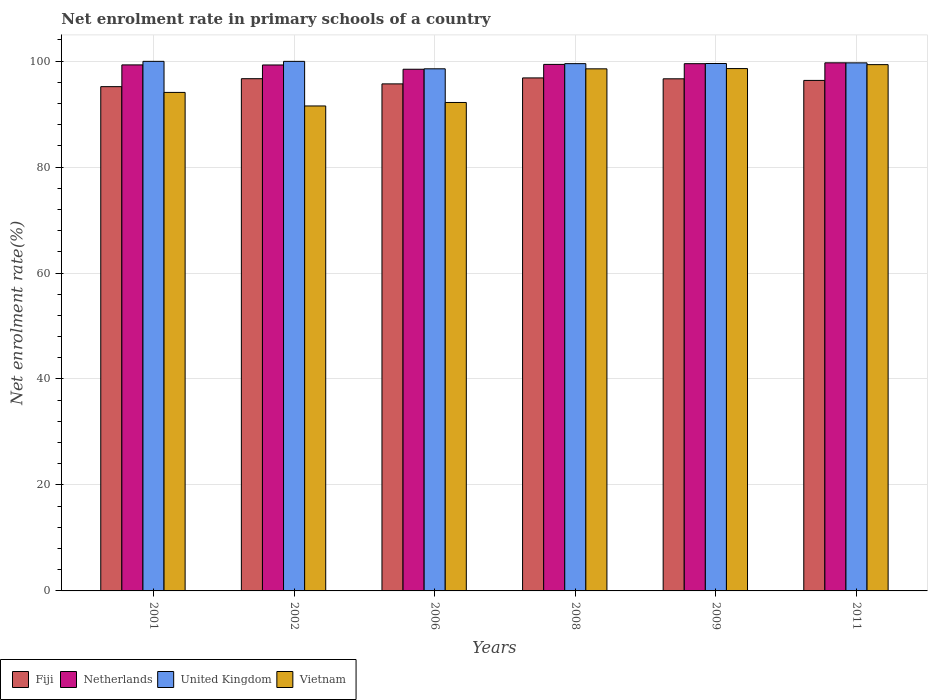How many different coloured bars are there?
Offer a terse response. 4. Are the number of bars on each tick of the X-axis equal?
Ensure brevity in your answer.  Yes. How many bars are there on the 6th tick from the left?
Offer a very short reply. 4. What is the net enrolment rate in primary schools in Vietnam in 2009?
Your answer should be very brief. 98.58. Across all years, what is the maximum net enrolment rate in primary schools in Vietnam?
Make the answer very short. 99.32. Across all years, what is the minimum net enrolment rate in primary schools in Vietnam?
Give a very brief answer. 91.53. In which year was the net enrolment rate in primary schools in Fiji minimum?
Provide a succinct answer. 2001. What is the total net enrolment rate in primary schools in Vietnam in the graph?
Ensure brevity in your answer.  574.23. What is the difference between the net enrolment rate in primary schools in Vietnam in 2009 and that in 2011?
Offer a very short reply. -0.74. What is the difference between the net enrolment rate in primary schools in United Kingdom in 2009 and the net enrolment rate in primary schools in Fiji in 2006?
Your answer should be compact. 3.85. What is the average net enrolment rate in primary schools in United Kingdom per year?
Offer a terse response. 99.52. In the year 2009, what is the difference between the net enrolment rate in primary schools in Fiji and net enrolment rate in primary schools in United Kingdom?
Your answer should be very brief. -2.89. In how many years, is the net enrolment rate in primary schools in Netherlands greater than 64 %?
Offer a very short reply. 6. What is the ratio of the net enrolment rate in primary schools in Fiji in 2001 to that in 2008?
Ensure brevity in your answer.  0.98. Is the net enrolment rate in primary schools in Vietnam in 2002 less than that in 2008?
Provide a succinct answer. Yes. What is the difference between the highest and the second highest net enrolment rate in primary schools in Netherlands?
Provide a short and direct response. 0.16. What is the difference between the highest and the lowest net enrolment rate in primary schools in United Kingdom?
Ensure brevity in your answer.  1.41. Is the sum of the net enrolment rate in primary schools in Vietnam in 2006 and 2011 greater than the maximum net enrolment rate in primary schools in Fiji across all years?
Your answer should be very brief. Yes. What does the 4th bar from the right in 2009 represents?
Ensure brevity in your answer.  Fiji. How many years are there in the graph?
Your response must be concise. 6. How many legend labels are there?
Provide a succinct answer. 4. What is the title of the graph?
Your answer should be very brief. Net enrolment rate in primary schools of a country. What is the label or title of the X-axis?
Provide a succinct answer. Years. What is the label or title of the Y-axis?
Your response must be concise. Net enrolment rate(%). What is the Net enrolment rate(%) of Fiji in 2001?
Provide a succinct answer. 95.17. What is the Net enrolment rate(%) of Netherlands in 2001?
Provide a succinct answer. 99.28. What is the Net enrolment rate(%) in United Kingdom in 2001?
Provide a succinct answer. 99.94. What is the Net enrolment rate(%) in Vietnam in 2001?
Ensure brevity in your answer.  94.08. What is the Net enrolment rate(%) in Fiji in 2002?
Offer a terse response. 96.67. What is the Net enrolment rate(%) of Netherlands in 2002?
Make the answer very short. 99.26. What is the Net enrolment rate(%) in United Kingdom in 2002?
Keep it short and to the point. 99.94. What is the Net enrolment rate(%) in Vietnam in 2002?
Ensure brevity in your answer.  91.53. What is the Net enrolment rate(%) of Fiji in 2006?
Your answer should be very brief. 95.69. What is the Net enrolment rate(%) in Netherlands in 2006?
Your answer should be very brief. 98.46. What is the Net enrolment rate(%) of United Kingdom in 2006?
Offer a terse response. 98.54. What is the Net enrolment rate(%) of Vietnam in 2006?
Your response must be concise. 92.18. What is the Net enrolment rate(%) of Fiji in 2008?
Offer a very short reply. 96.82. What is the Net enrolment rate(%) of Netherlands in 2008?
Offer a terse response. 99.37. What is the Net enrolment rate(%) in United Kingdom in 2008?
Make the answer very short. 99.51. What is the Net enrolment rate(%) of Vietnam in 2008?
Keep it short and to the point. 98.53. What is the Net enrolment rate(%) in Fiji in 2009?
Keep it short and to the point. 96.65. What is the Net enrolment rate(%) of Netherlands in 2009?
Provide a short and direct response. 99.5. What is the Net enrolment rate(%) in United Kingdom in 2009?
Keep it short and to the point. 99.54. What is the Net enrolment rate(%) in Vietnam in 2009?
Your answer should be very brief. 98.58. What is the Net enrolment rate(%) of Fiji in 2011?
Offer a terse response. 96.35. What is the Net enrolment rate(%) of Netherlands in 2011?
Keep it short and to the point. 99.67. What is the Net enrolment rate(%) in United Kingdom in 2011?
Offer a very short reply. 99.66. What is the Net enrolment rate(%) in Vietnam in 2011?
Offer a very short reply. 99.32. Across all years, what is the maximum Net enrolment rate(%) of Fiji?
Give a very brief answer. 96.82. Across all years, what is the maximum Net enrolment rate(%) in Netherlands?
Provide a short and direct response. 99.67. Across all years, what is the maximum Net enrolment rate(%) of United Kingdom?
Your answer should be compact. 99.94. Across all years, what is the maximum Net enrolment rate(%) of Vietnam?
Offer a very short reply. 99.32. Across all years, what is the minimum Net enrolment rate(%) of Fiji?
Keep it short and to the point. 95.17. Across all years, what is the minimum Net enrolment rate(%) in Netherlands?
Your answer should be very brief. 98.46. Across all years, what is the minimum Net enrolment rate(%) of United Kingdom?
Give a very brief answer. 98.54. Across all years, what is the minimum Net enrolment rate(%) of Vietnam?
Give a very brief answer. 91.53. What is the total Net enrolment rate(%) of Fiji in the graph?
Ensure brevity in your answer.  577.35. What is the total Net enrolment rate(%) in Netherlands in the graph?
Offer a very short reply. 595.54. What is the total Net enrolment rate(%) of United Kingdom in the graph?
Ensure brevity in your answer.  597.13. What is the total Net enrolment rate(%) of Vietnam in the graph?
Keep it short and to the point. 574.23. What is the difference between the Net enrolment rate(%) of Fiji in 2001 and that in 2002?
Provide a short and direct response. -1.5. What is the difference between the Net enrolment rate(%) in Netherlands in 2001 and that in 2002?
Keep it short and to the point. 0.01. What is the difference between the Net enrolment rate(%) in United Kingdom in 2001 and that in 2002?
Keep it short and to the point. 0. What is the difference between the Net enrolment rate(%) in Vietnam in 2001 and that in 2002?
Your answer should be compact. 2.56. What is the difference between the Net enrolment rate(%) of Fiji in 2001 and that in 2006?
Give a very brief answer. -0.52. What is the difference between the Net enrolment rate(%) of Netherlands in 2001 and that in 2006?
Keep it short and to the point. 0.82. What is the difference between the Net enrolment rate(%) of United Kingdom in 2001 and that in 2006?
Your answer should be very brief. 1.41. What is the difference between the Net enrolment rate(%) of Vietnam in 2001 and that in 2006?
Ensure brevity in your answer.  1.9. What is the difference between the Net enrolment rate(%) of Fiji in 2001 and that in 2008?
Keep it short and to the point. -1.65. What is the difference between the Net enrolment rate(%) of Netherlands in 2001 and that in 2008?
Your answer should be very brief. -0.09. What is the difference between the Net enrolment rate(%) in United Kingdom in 2001 and that in 2008?
Ensure brevity in your answer.  0.43. What is the difference between the Net enrolment rate(%) of Vietnam in 2001 and that in 2008?
Your response must be concise. -4.45. What is the difference between the Net enrolment rate(%) of Fiji in 2001 and that in 2009?
Provide a succinct answer. -1.48. What is the difference between the Net enrolment rate(%) of Netherlands in 2001 and that in 2009?
Your answer should be compact. -0.23. What is the difference between the Net enrolment rate(%) of United Kingdom in 2001 and that in 2009?
Your answer should be compact. 0.41. What is the difference between the Net enrolment rate(%) of Vietnam in 2001 and that in 2009?
Keep it short and to the point. -4.5. What is the difference between the Net enrolment rate(%) of Fiji in 2001 and that in 2011?
Offer a very short reply. -1.17. What is the difference between the Net enrolment rate(%) in Netherlands in 2001 and that in 2011?
Your answer should be very brief. -0.39. What is the difference between the Net enrolment rate(%) in United Kingdom in 2001 and that in 2011?
Keep it short and to the point. 0.29. What is the difference between the Net enrolment rate(%) in Vietnam in 2001 and that in 2011?
Your response must be concise. -5.24. What is the difference between the Net enrolment rate(%) in Fiji in 2002 and that in 2006?
Your answer should be compact. 0.98. What is the difference between the Net enrolment rate(%) of Netherlands in 2002 and that in 2006?
Provide a short and direct response. 0.81. What is the difference between the Net enrolment rate(%) of United Kingdom in 2002 and that in 2006?
Provide a short and direct response. 1.41. What is the difference between the Net enrolment rate(%) of Vietnam in 2002 and that in 2006?
Provide a succinct answer. -0.66. What is the difference between the Net enrolment rate(%) in Fiji in 2002 and that in 2008?
Your answer should be compact. -0.15. What is the difference between the Net enrolment rate(%) in Netherlands in 2002 and that in 2008?
Offer a terse response. -0.11. What is the difference between the Net enrolment rate(%) of United Kingdom in 2002 and that in 2008?
Your answer should be very brief. 0.43. What is the difference between the Net enrolment rate(%) of Vietnam in 2002 and that in 2008?
Offer a terse response. -7.01. What is the difference between the Net enrolment rate(%) in Fiji in 2002 and that in 2009?
Your answer should be very brief. 0.02. What is the difference between the Net enrolment rate(%) of Netherlands in 2002 and that in 2009?
Ensure brevity in your answer.  -0.24. What is the difference between the Net enrolment rate(%) of United Kingdom in 2002 and that in 2009?
Provide a succinct answer. 0.4. What is the difference between the Net enrolment rate(%) of Vietnam in 2002 and that in 2009?
Your answer should be very brief. -7.06. What is the difference between the Net enrolment rate(%) in Fiji in 2002 and that in 2011?
Give a very brief answer. 0.33. What is the difference between the Net enrolment rate(%) in Netherlands in 2002 and that in 2011?
Your answer should be compact. -0.41. What is the difference between the Net enrolment rate(%) of United Kingdom in 2002 and that in 2011?
Ensure brevity in your answer.  0.28. What is the difference between the Net enrolment rate(%) in Vietnam in 2002 and that in 2011?
Give a very brief answer. -7.8. What is the difference between the Net enrolment rate(%) in Fiji in 2006 and that in 2008?
Keep it short and to the point. -1.13. What is the difference between the Net enrolment rate(%) of Netherlands in 2006 and that in 2008?
Offer a very short reply. -0.91. What is the difference between the Net enrolment rate(%) in United Kingdom in 2006 and that in 2008?
Provide a short and direct response. -0.98. What is the difference between the Net enrolment rate(%) of Vietnam in 2006 and that in 2008?
Offer a terse response. -6.35. What is the difference between the Net enrolment rate(%) in Fiji in 2006 and that in 2009?
Provide a short and direct response. -0.96. What is the difference between the Net enrolment rate(%) in Netherlands in 2006 and that in 2009?
Your answer should be compact. -1.05. What is the difference between the Net enrolment rate(%) in United Kingdom in 2006 and that in 2009?
Ensure brevity in your answer.  -1. What is the difference between the Net enrolment rate(%) in Vietnam in 2006 and that in 2009?
Provide a succinct answer. -6.4. What is the difference between the Net enrolment rate(%) in Fiji in 2006 and that in 2011?
Ensure brevity in your answer.  -0.65. What is the difference between the Net enrolment rate(%) of Netherlands in 2006 and that in 2011?
Keep it short and to the point. -1.21. What is the difference between the Net enrolment rate(%) in United Kingdom in 2006 and that in 2011?
Provide a succinct answer. -1.12. What is the difference between the Net enrolment rate(%) in Vietnam in 2006 and that in 2011?
Offer a terse response. -7.14. What is the difference between the Net enrolment rate(%) in Fiji in 2008 and that in 2009?
Keep it short and to the point. 0.17. What is the difference between the Net enrolment rate(%) of Netherlands in 2008 and that in 2009?
Provide a short and direct response. -0.13. What is the difference between the Net enrolment rate(%) of United Kingdom in 2008 and that in 2009?
Your answer should be compact. -0.03. What is the difference between the Net enrolment rate(%) in Vietnam in 2008 and that in 2009?
Offer a very short reply. -0.05. What is the difference between the Net enrolment rate(%) of Fiji in 2008 and that in 2011?
Your response must be concise. 0.47. What is the difference between the Net enrolment rate(%) in Netherlands in 2008 and that in 2011?
Give a very brief answer. -0.3. What is the difference between the Net enrolment rate(%) of United Kingdom in 2008 and that in 2011?
Ensure brevity in your answer.  -0.15. What is the difference between the Net enrolment rate(%) of Vietnam in 2008 and that in 2011?
Provide a succinct answer. -0.79. What is the difference between the Net enrolment rate(%) of Fiji in 2009 and that in 2011?
Give a very brief answer. 0.31. What is the difference between the Net enrolment rate(%) in Netherlands in 2009 and that in 2011?
Your response must be concise. -0.16. What is the difference between the Net enrolment rate(%) in United Kingdom in 2009 and that in 2011?
Your answer should be compact. -0.12. What is the difference between the Net enrolment rate(%) in Vietnam in 2009 and that in 2011?
Make the answer very short. -0.74. What is the difference between the Net enrolment rate(%) of Fiji in 2001 and the Net enrolment rate(%) of Netherlands in 2002?
Your answer should be compact. -4.09. What is the difference between the Net enrolment rate(%) of Fiji in 2001 and the Net enrolment rate(%) of United Kingdom in 2002?
Make the answer very short. -4.77. What is the difference between the Net enrolment rate(%) of Fiji in 2001 and the Net enrolment rate(%) of Vietnam in 2002?
Your answer should be compact. 3.65. What is the difference between the Net enrolment rate(%) in Netherlands in 2001 and the Net enrolment rate(%) in Vietnam in 2002?
Offer a very short reply. 7.75. What is the difference between the Net enrolment rate(%) in United Kingdom in 2001 and the Net enrolment rate(%) in Vietnam in 2002?
Your answer should be compact. 8.42. What is the difference between the Net enrolment rate(%) of Fiji in 2001 and the Net enrolment rate(%) of Netherlands in 2006?
Give a very brief answer. -3.28. What is the difference between the Net enrolment rate(%) in Fiji in 2001 and the Net enrolment rate(%) in United Kingdom in 2006?
Make the answer very short. -3.37. What is the difference between the Net enrolment rate(%) of Fiji in 2001 and the Net enrolment rate(%) of Vietnam in 2006?
Keep it short and to the point. 2.99. What is the difference between the Net enrolment rate(%) of Netherlands in 2001 and the Net enrolment rate(%) of United Kingdom in 2006?
Offer a terse response. 0.74. What is the difference between the Net enrolment rate(%) in Netherlands in 2001 and the Net enrolment rate(%) in Vietnam in 2006?
Give a very brief answer. 7.09. What is the difference between the Net enrolment rate(%) of United Kingdom in 2001 and the Net enrolment rate(%) of Vietnam in 2006?
Keep it short and to the point. 7.76. What is the difference between the Net enrolment rate(%) of Fiji in 2001 and the Net enrolment rate(%) of Netherlands in 2008?
Provide a succinct answer. -4.2. What is the difference between the Net enrolment rate(%) of Fiji in 2001 and the Net enrolment rate(%) of United Kingdom in 2008?
Keep it short and to the point. -4.34. What is the difference between the Net enrolment rate(%) in Fiji in 2001 and the Net enrolment rate(%) in Vietnam in 2008?
Keep it short and to the point. -3.36. What is the difference between the Net enrolment rate(%) of Netherlands in 2001 and the Net enrolment rate(%) of United Kingdom in 2008?
Give a very brief answer. -0.24. What is the difference between the Net enrolment rate(%) in Netherlands in 2001 and the Net enrolment rate(%) in Vietnam in 2008?
Provide a short and direct response. 0.75. What is the difference between the Net enrolment rate(%) in United Kingdom in 2001 and the Net enrolment rate(%) in Vietnam in 2008?
Your response must be concise. 1.41. What is the difference between the Net enrolment rate(%) in Fiji in 2001 and the Net enrolment rate(%) in Netherlands in 2009?
Offer a very short reply. -4.33. What is the difference between the Net enrolment rate(%) of Fiji in 2001 and the Net enrolment rate(%) of United Kingdom in 2009?
Make the answer very short. -4.37. What is the difference between the Net enrolment rate(%) in Fiji in 2001 and the Net enrolment rate(%) in Vietnam in 2009?
Provide a succinct answer. -3.41. What is the difference between the Net enrolment rate(%) in Netherlands in 2001 and the Net enrolment rate(%) in United Kingdom in 2009?
Make the answer very short. -0.26. What is the difference between the Net enrolment rate(%) of Netherlands in 2001 and the Net enrolment rate(%) of Vietnam in 2009?
Your answer should be compact. 0.69. What is the difference between the Net enrolment rate(%) in United Kingdom in 2001 and the Net enrolment rate(%) in Vietnam in 2009?
Provide a short and direct response. 1.36. What is the difference between the Net enrolment rate(%) of Fiji in 2001 and the Net enrolment rate(%) of Netherlands in 2011?
Make the answer very short. -4.5. What is the difference between the Net enrolment rate(%) in Fiji in 2001 and the Net enrolment rate(%) in United Kingdom in 2011?
Give a very brief answer. -4.49. What is the difference between the Net enrolment rate(%) in Fiji in 2001 and the Net enrolment rate(%) in Vietnam in 2011?
Your answer should be compact. -4.15. What is the difference between the Net enrolment rate(%) of Netherlands in 2001 and the Net enrolment rate(%) of United Kingdom in 2011?
Your answer should be very brief. -0.38. What is the difference between the Net enrolment rate(%) of Netherlands in 2001 and the Net enrolment rate(%) of Vietnam in 2011?
Offer a very short reply. -0.05. What is the difference between the Net enrolment rate(%) in United Kingdom in 2001 and the Net enrolment rate(%) in Vietnam in 2011?
Ensure brevity in your answer.  0.62. What is the difference between the Net enrolment rate(%) in Fiji in 2002 and the Net enrolment rate(%) in Netherlands in 2006?
Provide a short and direct response. -1.78. What is the difference between the Net enrolment rate(%) in Fiji in 2002 and the Net enrolment rate(%) in United Kingdom in 2006?
Offer a terse response. -1.86. What is the difference between the Net enrolment rate(%) of Fiji in 2002 and the Net enrolment rate(%) of Vietnam in 2006?
Keep it short and to the point. 4.49. What is the difference between the Net enrolment rate(%) of Netherlands in 2002 and the Net enrolment rate(%) of United Kingdom in 2006?
Give a very brief answer. 0.72. What is the difference between the Net enrolment rate(%) in Netherlands in 2002 and the Net enrolment rate(%) in Vietnam in 2006?
Provide a succinct answer. 7.08. What is the difference between the Net enrolment rate(%) in United Kingdom in 2002 and the Net enrolment rate(%) in Vietnam in 2006?
Your answer should be very brief. 7.76. What is the difference between the Net enrolment rate(%) in Fiji in 2002 and the Net enrolment rate(%) in Netherlands in 2008?
Keep it short and to the point. -2.7. What is the difference between the Net enrolment rate(%) in Fiji in 2002 and the Net enrolment rate(%) in United Kingdom in 2008?
Give a very brief answer. -2.84. What is the difference between the Net enrolment rate(%) of Fiji in 2002 and the Net enrolment rate(%) of Vietnam in 2008?
Ensure brevity in your answer.  -1.86. What is the difference between the Net enrolment rate(%) of Netherlands in 2002 and the Net enrolment rate(%) of United Kingdom in 2008?
Provide a short and direct response. -0.25. What is the difference between the Net enrolment rate(%) in Netherlands in 2002 and the Net enrolment rate(%) in Vietnam in 2008?
Provide a succinct answer. 0.73. What is the difference between the Net enrolment rate(%) in United Kingdom in 2002 and the Net enrolment rate(%) in Vietnam in 2008?
Your answer should be very brief. 1.41. What is the difference between the Net enrolment rate(%) of Fiji in 2002 and the Net enrolment rate(%) of Netherlands in 2009?
Provide a succinct answer. -2.83. What is the difference between the Net enrolment rate(%) in Fiji in 2002 and the Net enrolment rate(%) in United Kingdom in 2009?
Keep it short and to the point. -2.87. What is the difference between the Net enrolment rate(%) in Fiji in 2002 and the Net enrolment rate(%) in Vietnam in 2009?
Provide a short and direct response. -1.91. What is the difference between the Net enrolment rate(%) of Netherlands in 2002 and the Net enrolment rate(%) of United Kingdom in 2009?
Ensure brevity in your answer.  -0.28. What is the difference between the Net enrolment rate(%) in Netherlands in 2002 and the Net enrolment rate(%) in Vietnam in 2009?
Ensure brevity in your answer.  0.68. What is the difference between the Net enrolment rate(%) of United Kingdom in 2002 and the Net enrolment rate(%) of Vietnam in 2009?
Make the answer very short. 1.36. What is the difference between the Net enrolment rate(%) of Fiji in 2002 and the Net enrolment rate(%) of Netherlands in 2011?
Provide a succinct answer. -3. What is the difference between the Net enrolment rate(%) in Fiji in 2002 and the Net enrolment rate(%) in United Kingdom in 2011?
Give a very brief answer. -2.99. What is the difference between the Net enrolment rate(%) in Fiji in 2002 and the Net enrolment rate(%) in Vietnam in 2011?
Ensure brevity in your answer.  -2.65. What is the difference between the Net enrolment rate(%) of Netherlands in 2002 and the Net enrolment rate(%) of United Kingdom in 2011?
Provide a succinct answer. -0.4. What is the difference between the Net enrolment rate(%) in Netherlands in 2002 and the Net enrolment rate(%) in Vietnam in 2011?
Provide a short and direct response. -0.06. What is the difference between the Net enrolment rate(%) in United Kingdom in 2002 and the Net enrolment rate(%) in Vietnam in 2011?
Keep it short and to the point. 0.62. What is the difference between the Net enrolment rate(%) of Fiji in 2006 and the Net enrolment rate(%) of Netherlands in 2008?
Make the answer very short. -3.68. What is the difference between the Net enrolment rate(%) of Fiji in 2006 and the Net enrolment rate(%) of United Kingdom in 2008?
Offer a terse response. -3.82. What is the difference between the Net enrolment rate(%) in Fiji in 2006 and the Net enrolment rate(%) in Vietnam in 2008?
Ensure brevity in your answer.  -2.84. What is the difference between the Net enrolment rate(%) of Netherlands in 2006 and the Net enrolment rate(%) of United Kingdom in 2008?
Make the answer very short. -1.06. What is the difference between the Net enrolment rate(%) in Netherlands in 2006 and the Net enrolment rate(%) in Vietnam in 2008?
Offer a very short reply. -0.07. What is the difference between the Net enrolment rate(%) of United Kingdom in 2006 and the Net enrolment rate(%) of Vietnam in 2008?
Make the answer very short. 0.01. What is the difference between the Net enrolment rate(%) of Fiji in 2006 and the Net enrolment rate(%) of Netherlands in 2009?
Give a very brief answer. -3.81. What is the difference between the Net enrolment rate(%) of Fiji in 2006 and the Net enrolment rate(%) of United Kingdom in 2009?
Make the answer very short. -3.85. What is the difference between the Net enrolment rate(%) in Fiji in 2006 and the Net enrolment rate(%) in Vietnam in 2009?
Your response must be concise. -2.89. What is the difference between the Net enrolment rate(%) in Netherlands in 2006 and the Net enrolment rate(%) in United Kingdom in 2009?
Offer a very short reply. -1.08. What is the difference between the Net enrolment rate(%) of Netherlands in 2006 and the Net enrolment rate(%) of Vietnam in 2009?
Keep it short and to the point. -0.13. What is the difference between the Net enrolment rate(%) in United Kingdom in 2006 and the Net enrolment rate(%) in Vietnam in 2009?
Your response must be concise. -0.04. What is the difference between the Net enrolment rate(%) of Fiji in 2006 and the Net enrolment rate(%) of Netherlands in 2011?
Your response must be concise. -3.98. What is the difference between the Net enrolment rate(%) in Fiji in 2006 and the Net enrolment rate(%) in United Kingdom in 2011?
Your response must be concise. -3.97. What is the difference between the Net enrolment rate(%) in Fiji in 2006 and the Net enrolment rate(%) in Vietnam in 2011?
Make the answer very short. -3.63. What is the difference between the Net enrolment rate(%) in Netherlands in 2006 and the Net enrolment rate(%) in United Kingdom in 2011?
Ensure brevity in your answer.  -1.2. What is the difference between the Net enrolment rate(%) in Netherlands in 2006 and the Net enrolment rate(%) in Vietnam in 2011?
Your response must be concise. -0.87. What is the difference between the Net enrolment rate(%) of United Kingdom in 2006 and the Net enrolment rate(%) of Vietnam in 2011?
Ensure brevity in your answer.  -0.79. What is the difference between the Net enrolment rate(%) of Fiji in 2008 and the Net enrolment rate(%) of Netherlands in 2009?
Ensure brevity in your answer.  -2.69. What is the difference between the Net enrolment rate(%) in Fiji in 2008 and the Net enrolment rate(%) in United Kingdom in 2009?
Your answer should be compact. -2.72. What is the difference between the Net enrolment rate(%) in Fiji in 2008 and the Net enrolment rate(%) in Vietnam in 2009?
Provide a short and direct response. -1.76. What is the difference between the Net enrolment rate(%) of Netherlands in 2008 and the Net enrolment rate(%) of United Kingdom in 2009?
Your answer should be compact. -0.17. What is the difference between the Net enrolment rate(%) in Netherlands in 2008 and the Net enrolment rate(%) in Vietnam in 2009?
Ensure brevity in your answer.  0.79. What is the difference between the Net enrolment rate(%) in United Kingdom in 2008 and the Net enrolment rate(%) in Vietnam in 2009?
Ensure brevity in your answer.  0.93. What is the difference between the Net enrolment rate(%) of Fiji in 2008 and the Net enrolment rate(%) of Netherlands in 2011?
Your answer should be very brief. -2.85. What is the difference between the Net enrolment rate(%) of Fiji in 2008 and the Net enrolment rate(%) of United Kingdom in 2011?
Make the answer very short. -2.84. What is the difference between the Net enrolment rate(%) of Fiji in 2008 and the Net enrolment rate(%) of Vietnam in 2011?
Your answer should be compact. -2.51. What is the difference between the Net enrolment rate(%) in Netherlands in 2008 and the Net enrolment rate(%) in United Kingdom in 2011?
Your answer should be compact. -0.29. What is the difference between the Net enrolment rate(%) in Netherlands in 2008 and the Net enrolment rate(%) in Vietnam in 2011?
Make the answer very short. 0.05. What is the difference between the Net enrolment rate(%) in United Kingdom in 2008 and the Net enrolment rate(%) in Vietnam in 2011?
Your answer should be very brief. 0.19. What is the difference between the Net enrolment rate(%) of Fiji in 2009 and the Net enrolment rate(%) of Netherlands in 2011?
Make the answer very short. -3.02. What is the difference between the Net enrolment rate(%) in Fiji in 2009 and the Net enrolment rate(%) in United Kingdom in 2011?
Give a very brief answer. -3.01. What is the difference between the Net enrolment rate(%) in Fiji in 2009 and the Net enrolment rate(%) in Vietnam in 2011?
Your answer should be compact. -2.67. What is the difference between the Net enrolment rate(%) of Netherlands in 2009 and the Net enrolment rate(%) of United Kingdom in 2011?
Provide a short and direct response. -0.15. What is the difference between the Net enrolment rate(%) of Netherlands in 2009 and the Net enrolment rate(%) of Vietnam in 2011?
Provide a succinct answer. 0.18. What is the difference between the Net enrolment rate(%) in United Kingdom in 2009 and the Net enrolment rate(%) in Vietnam in 2011?
Ensure brevity in your answer.  0.21. What is the average Net enrolment rate(%) of Fiji per year?
Your response must be concise. 96.23. What is the average Net enrolment rate(%) in Netherlands per year?
Make the answer very short. 99.26. What is the average Net enrolment rate(%) in United Kingdom per year?
Offer a terse response. 99.52. What is the average Net enrolment rate(%) in Vietnam per year?
Give a very brief answer. 95.7. In the year 2001, what is the difference between the Net enrolment rate(%) in Fiji and Net enrolment rate(%) in Netherlands?
Offer a terse response. -4.11. In the year 2001, what is the difference between the Net enrolment rate(%) in Fiji and Net enrolment rate(%) in United Kingdom?
Provide a succinct answer. -4.77. In the year 2001, what is the difference between the Net enrolment rate(%) in Fiji and Net enrolment rate(%) in Vietnam?
Provide a succinct answer. 1.09. In the year 2001, what is the difference between the Net enrolment rate(%) of Netherlands and Net enrolment rate(%) of United Kingdom?
Provide a short and direct response. -0.67. In the year 2001, what is the difference between the Net enrolment rate(%) of Netherlands and Net enrolment rate(%) of Vietnam?
Your answer should be compact. 5.19. In the year 2001, what is the difference between the Net enrolment rate(%) in United Kingdom and Net enrolment rate(%) in Vietnam?
Provide a succinct answer. 5.86. In the year 2002, what is the difference between the Net enrolment rate(%) in Fiji and Net enrolment rate(%) in Netherlands?
Make the answer very short. -2.59. In the year 2002, what is the difference between the Net enrolment rate(%) in Fiji and Net enrolment rate(%) in United Kingdom?
Offer a terse response. -3.27. In the year 2002, what is the difference between the Net enrolment rate(%) in Fiji and Net enrolment rate(%) in Vietnam?
Ensure brevity in your answer.  5.15. In the year 2002, what is the difference between the Net enrolment rate(%) in Netherlands and Net enrolment rate(%) in United Kingdom?
Your answer should be compact. -0.68. In the year 2002, what is the difference between the Net enrolment rate(%) of Netherlands and Net enrolment rate(%) of Vietnam?
Offer a very short reply. 7.74. In the year 2002, what is the difference between the Net enrolment rate(%) in United Kingdom and Net enrolment rate(%) in Vietnam?
Keep it short and to the point. 8.42. In the year 2006, what is the difference between the Net enrolment rate(%) in Fiji and Net enrolment rate(%) in Netherlands?
Give a very brief answer. -2.76. In the year 2006, what is the difference between the Net enrolment rate(%) in Fiji and Net enrolment rate(%) in United Kingdom?
Keep it short and to the point. -2.84. In the year 2006, what is the difference between the Net enrolment rate(%) in Fiji and Net enrolment rate(%) in Vietnam?
Offer a terse response. 3.51. In the year 2006, what is the difference between the Net enrolment rate(%) in Netherlands and Net enrolment rate(%) in United Kingdom?
Your response must be concise. -0.08. In the year 2006, what is the difference between the Net enrolment rate(%) in Netherlands and Net enrolment rate(%) in Vietnam?
Give a very brief answer. 6.27. In the year 2006, what is the difference between the Net enrolment rate(%) in United Kingdom and Net enrolment rate(%) in Vietnam?
Make the answer very short. 6.35. In the year 2008, what is the difference between the Net enrolment rate(%) of Fiji and Net enrolment rate(%) of Netherlands?
Provide a succinct answer. -2.55. In the year 2008, what is the difference between the Net enrolment rate(%) in Fiji and Net enrolment rate(%) in United Kingdom?
Your response must be concise. -2.69. In the year 2008, what is the difference between the Net enrolment rate(%) in Fiji and Net enrolment rate(%) in Vietnam?
Your response must be concise. -1.71. In the year 2008, what is the difference between the Net enrolment rate(%) in Netherlands and Net enrolment rate(%) in United Kingdom?
Keep it short and to the point. -0.14. In the year 2008, what is the difference between the Net enrolment rate(%) of Netherlands and Net enrolment rate(%) of Vietnam?
Offer a very short reply. 0.84. In the year 2008, what is the difference between the Net enrolment rate(%) of United Kingdom and Net enrolment rate(%) of Vietnam?
Your response must be concise. 0.98. In the year 2009, what is the difference between the Net enrolment rate(%) of Fiji and Net enrolment rate(%) of Netherlands?
Your answer should be compact. -2.85. In the year 2009, what is the difference between the Net enrolment rate(%) in Fiji and Net enrolment rate(%) in United Kingdom?
Your answer should be compact. -2.89. In the year 2009, what is the difference between the Net enrolment rate(%) in Fiji and Net enrolment rate(%) in Vietnam?
Your answer should be very brief. -1.93. In the year 2009, what is the difference between the Net enrolment rate(%) in Netherlands and Net enrolment rate(%) in United Kingdom?
Make the answer very short. -0.03. In the year 2009, what is the difference between the Net enrolment rate(%) of Netherlands and Net enrolment rate(%) of Vietnam?
Keep it short and to the point. 0.92. In the year 2009, what is the difference between the Net enrolment rate(%) of United Kingdom and Net enrolment rate(%) of Vietnam?
Offer a terse response. 0.96. In the year 2011, what is the difference between the Net enrolment rate(%) of Fiji and Net enrolment rate(%) of Netherlands?
Offer a terse response. -3.32. In the year 2011, what is the difference between the Net enrolment rate(%) in Fiji and Net enrolment rate(%) in United Kingdom?
Offer a terse response. -3.31. In the year 2011, what is the difference between the Net enrolment rate(%) in Fiji and Net enrolment rate(%) in Vietnam?
Provide a short and direct response. -2.98. In the year 2011, what is the difference between the Net enrolment rate(%) in Netherlands and Net enrolment rate(%) in United Kingdom?
Provide a succinct answer. 0.01. In the year 2011, what is the difference between the Net enrolment rate(%) of Netherlands and Net enrolment rate(%) of Vietnam?
Offer a terse response. 0.34. In the year 2011, what is the difference between the Net enrolment rate(%) in United Kingdom and Net enrolment rate(%) in Vietnam?
Give a very brief answer. 0.33. What is the ratio of the Net enrolment rate(%) of Fiji in 2001 to that in 2002?
Your answer should be very brief. 0.98. What is the ratio of the Net enrolment rate(%) of United Kingdom in 2001 to that in 2002?
Give a very brief answer. 1. What is the ratio of the Net enrolment rate(%) in Vietnam in 2001 to that in 2002?
Make the answer very short. 1.03. What is the ratio of the Net enrolment rate(%) of Netherlands in 2001 to that in 2006?
Provide a short and direct response. 1.01. What is the ratio of the Net enrolment rate(%) in United Kingdom in 2001 to that in 2006?
Provide a succinct answer. 1.01. What is the ratio of the Net enrolment rate(%) in Vietnam in 2001 to that in 2006?
Provide a succinct answer. 1.02. What is the ratio of the Net enrolment rate(%) in Fiji in 2001 to that in 2008?
Provide a short and direct response. 0.98. What is the ratio of the Net enrolment rate(%) in Vietnam in 2001 to that in 2008?
Your answer should be compact. 0.95. What is the ratio of the Net enrolment rate(%) of Fiji in 2001 to that in 2009?
Your answer should be compact. 0.98. What is the ratio of the Net enrolment rate(%) of Netherlands in 2001 to that in 2009?
Make the answer very short. 1. What is the ratio of the Net enrolment rate(%) in United Kingdom in 2001 to that in 2009?
Provide a succinct answer. 1. What is the ratio of the Net enrolment rate(%) of Vietnam in 2001 to that in 2009?
Provide a succinct answer. 0.95. What is the ratio of the Net enrolment rate(%) in Netherlands in 2001 to that in 2011?
Your answer should be very brief. 1. What is the ratio of the Net enrolment rate(%) of Vietnam in 2001 to that in 2011?
Ensure brevity in your answer.  0.95. What is the ratio of the Net enrolment rate(%) in Fiji in 2002 to that in 2006?
Make the answer very short. 1.01. What is the ratio of the Net enrolment rate(%) of Netherlands in 2002 to that in 2006?
Make the answer very short. 1.01. What is the ratio of the Net enrolment rate(%) in United Kingdom in 2002 to that in 2006?
Offer a very short reply. 1.01. What is the ratio of the Net enrolment rate(%) of Vietnam in 2002 to that in 2006?
Ensure brevity in your answer.  0.99. What is the ratio of the Net enrolment rate(%) in Fiji in 2002 to that in 2008?
Offer a very short reply. 1. What is the ratio of the Net enrolment rate(%) in Vietnam in 2002 to that in 2008?
Your answer should be very brief. 0.93. What is the ratio of the Net enrolment rate(%) of United Kingdom in 2002 to that in 2009?
Your response must be concise. 1. What is the ratio of the Net enrolment rate(%) of Vietnam in 2002 to that in 2009?
Provide a succinct answer. 0.93. What is the ratio of the Net enrolment rate(%) of Fiji in 2002 to that in 2011?
Make the answer very short. 1. What is the ratio of the Net enrolment rate(%) of United Kingdom in 2002 to that in 2011?
Offer a terse response. 1. What is the ratio of the Net enrolment rate(%) of Vietnam in 2002 to that in 2011?
Provide a short and direct response. 0.92. What is the ratio of the Net enrolment rate(%) of Fiji in 2006 to that in 2008?
Provide a succinct answer. 0.99. What is the ratio of the Net enrolment rate(%) in Netherlands in 2006 to that in 2008?
Give a very brief answer. 0.99. What is the ratio of the Net enrolment rate(%) in United Kingdom in 2006 to that in 2008?
Make the answer very short. 0.99. What is the ratio of the Net enrolment rate(%) of Vietnam in 2006 to that in 2008?
Your answer should be very brief. 0.94. What is the ratio of the Net enrolment rate(%) of Vietnam in 2006 to that in 2009?
Offer a terse response. 0.94. What is the ratio of the Net enrolment rate(%) in Fiji in 2006 to that in 2011?
Provide a short and direct response. 0.99. What is the ratio of the Net enrolment rate(%) of Netherlands in 2006 to that in 2011?
Provide a short and direct response. 0.99. What is the ratio of the Net enrolment rate(%) in United Kingdom in 2006 to that in 2011?
Provide a succinct answer. 0.99. What is the ratio of the Net enrolment rate(%) of Vietnam in 2006 to that in 2011?
Keep it short and to the point. 0.93. What is the ratio of the Net enrolment rate(%) of Netherlands in 2008 to that in 2009?
Provide a short and direct response. 1. What is the ratio of the Net enrolment rate(%) of Vietnam in 2008 to that in 2009?
Your answer should be compact. 1. What is the ratio of the Net enrolment rate(%) in Fiji in 2008 to that in 2011?
Provide a succinct answer. 1. What is the ratio of the Net enrolment rate(%) in Netherlands in 2008 to that in 2011?
Keep it short and to the point. 1. What is the ratio of the Net enrolment rate(%) in United Kingdom in 2008 to that in 2011?
Keep it short and to the point. 1. What is the ratio of the Net enrolment rate(%) in Fiji in 2009 to that in 2011?
Your answer should be very brief. 1. What is the difference between the highest and the second highest Net enrolment rate(%) in Fiji?
Make the answer very short. 0.15. What is the difference between the highest and the second highest Net enrolment rate(%) in Netherlands?
Keep it short and to the point. 0.16. What is the difference between the highest and the second highest Net enrolment rate(%) in United Kingdom?
Your response must be concise. 0. What is the difference between the highest and the second highest Net enrolment rate(%) of Vietnam?
Your answer should be compact. 0.74. What is the difference between the highest and the lowest Net enrolment rate(%) in Fiji?
Offer a very short reply. 1.65. What is the difference between the highest and the lowest Net enrolment rate(%) of Netherlands?
Ensure brevity in your answer.  1.21. What is the difference between the highest and the lowest Net enrolment rate(%) in United Kingdom?
Make the answer very short. 1.41. What is the difference between the highest and the lowest Net enrolment rate(%) in Vietnam?
Give a very brief answer. 7.8. 